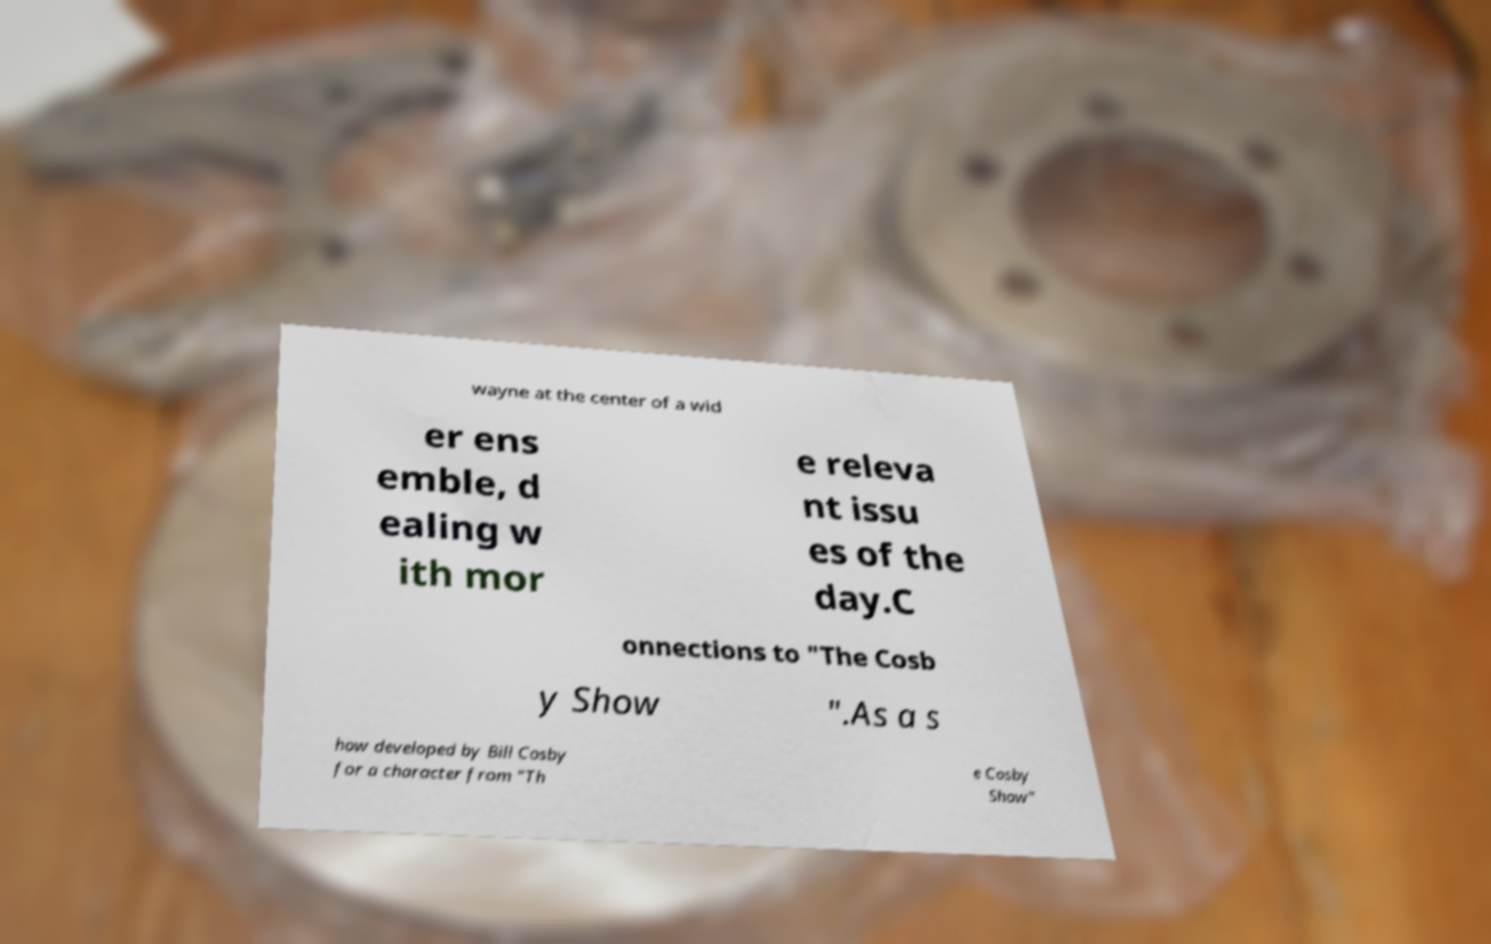Could you extract and type out the text from this image? wayne at the center of a wid er ens emble, d ealing w ith mor e releva nt issu es of the day.C onnections to "The Cosb y Show ".As a s how developed by Bill Cosby for a character from "Th e Cosby Show" 